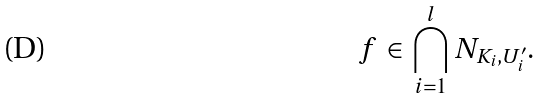Convert formula to latex. <formula><loc_0><loc_0><loc_500><loc_500>f \in \bigcap _ { i = 1 } ^ { l } N _ { K _ { i } , U ^ { \prime } _ { i } } .</formula> 